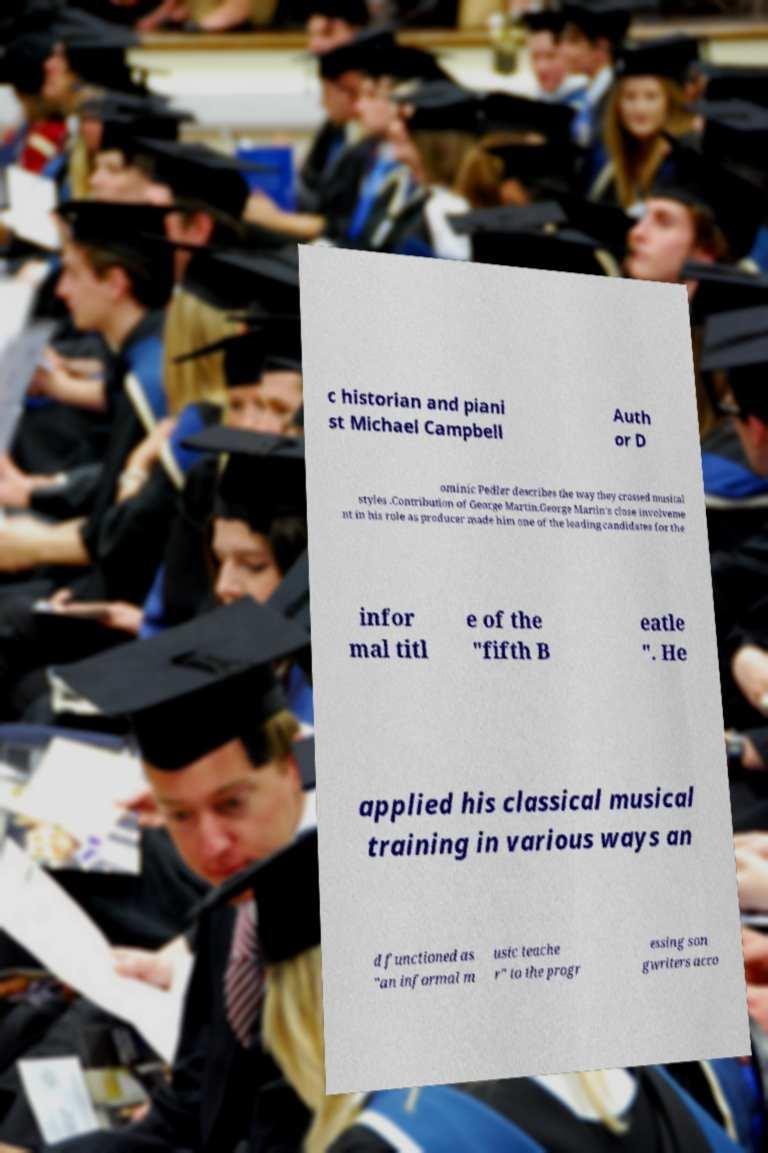Please read and relay the text visible in this image. What does it say? c historian and piani st Michael Campbell Auth or D ominic Pedler describes the way they crossed musical styles .Contribution of George Martin.George Martin's close involveme nt in his role as producer made him one of the leading candidates for the infor mal titl e of the "fifth B eatle ". He applied his classical musical training in various ways an d functioned as "an informal m usic teache r" to the progr essing son gwriters acco 